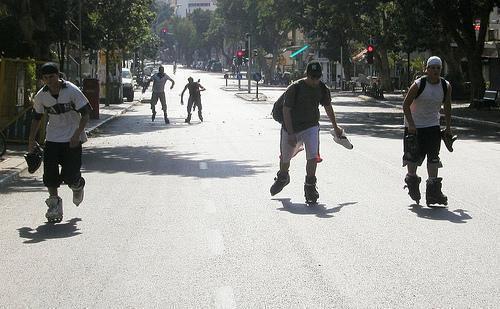What enables these people to go faster on the street?
Select the accurate answer and provide explanation: 'Answer: answer
Rationale: rationale.'
Options: Roller blades, ice skates, skate boards, roller skates. Answer: roller blades.
Rationale: The people are wearing skates with inline wheels in the street. 